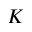<formula> <loc_0><loc_0><loc_500><loc_500>K</formula> 